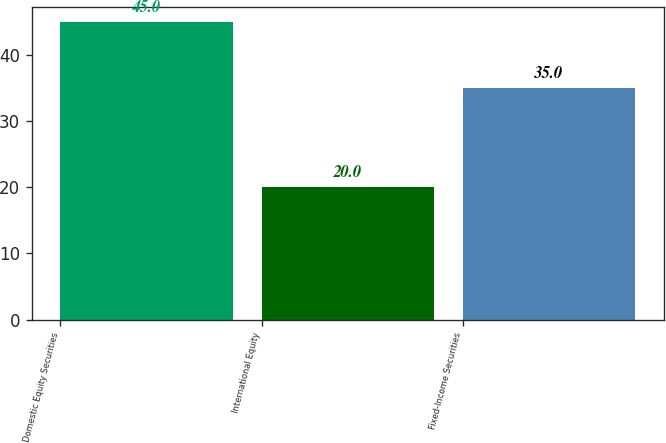Convert chart. <chart><loc_0><loc_0><loc_500><loc_500><bar_chart><fcel>Domestic Equity Securities<fcel>International Equity<fcel>Fixed-Income Securities<nl><fcel>45<fcel>20<fcel>35<nl></chart> 